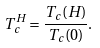Convert formula to latex. <formula><loc_0><loc_0><loc_500><loc_500>T _ { c } ^ { H } = \frac { T _ { c } ( H ) } { T _ { c } ( 0 ) } .</formula> 